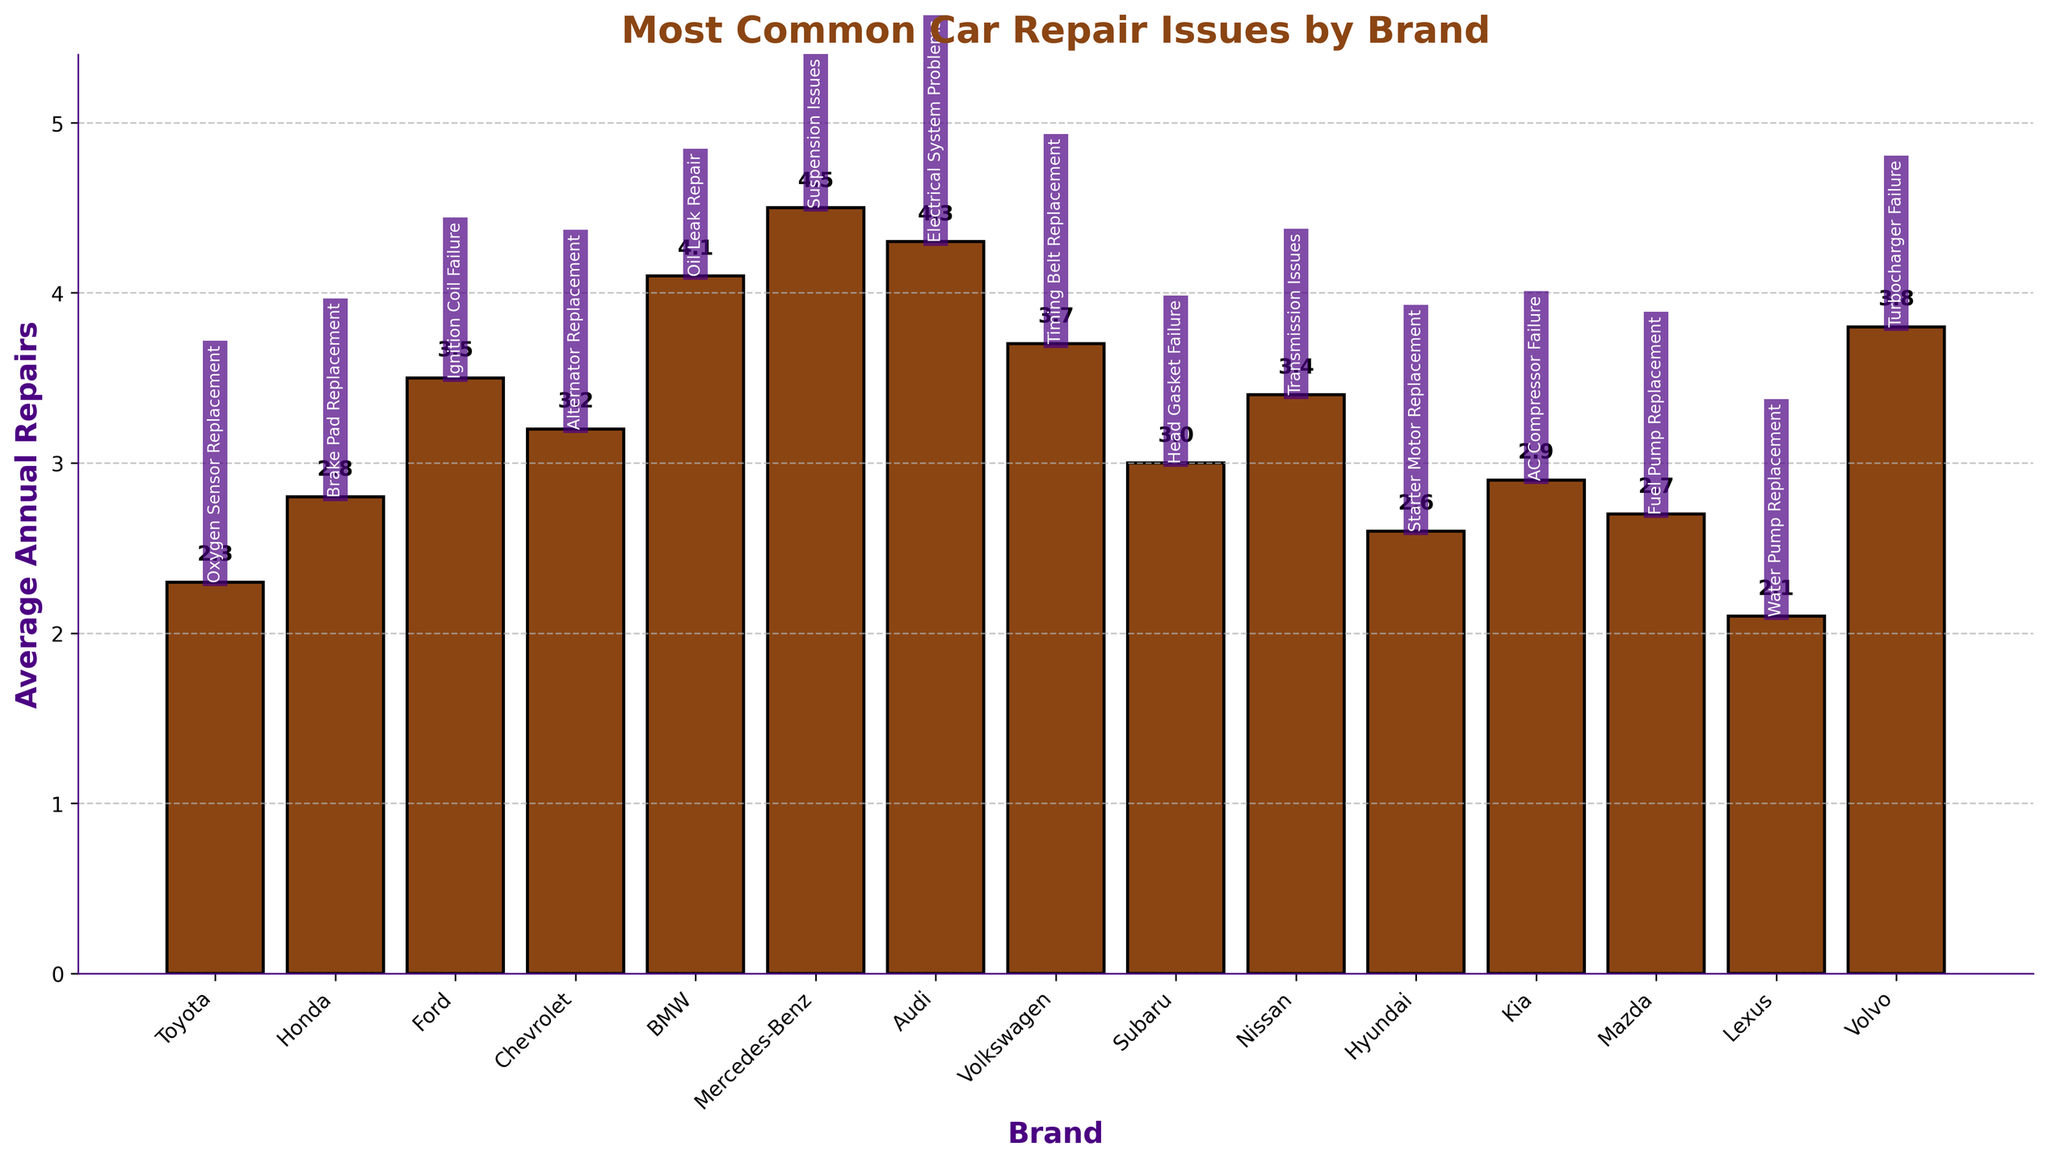Which brand has the highest average annual repairs? By inspecting the height of the bars in the chart, we can see that the bar representing Mercedes-Benz is the tallest, indicating the highest average annual repairs.
Answer: Mercedes-Benz Which brand has fewer average annual repairs, Honda or Kia? Compare the heights of the bars representing Honda and Kia. Honda has a height of 2.8 and Kia has a height of 2.9. Since 2.8 is less than 2.9, Honda has fewer average annual repairs than Kia.
Answer: Honda What is the difference in average annual repairs between BMW and Hyundai? The height of the BMW bar is 4.1 and the height of the Hyundai bar is 2.6. Subtracting these values gives 4.1 - 2.6 = 1.5.
Answer: 1.5 How many brands have an average annual repair value above 3.5? Identify and count the brands with bars exceeding the 3.5 mark. Mercedes-Benz (4.5), Audi (4.3), Volvo (3.8), and BMW (4.1) meet this criterion. There are 4 such brands.
Answer: 4 Which brands have an equal average annual repair frequency? Look for bars of equal height in the chart. Upon inspection, no two bars have exactly the same height, indicating that no brands have an equal average annual repair frequency.
Answer: None What is the most common repair issue for Toyota and how many average annual repairs does it have? Find the Toyota bar and look at the associated label above it. It shows "Oxygen Sensor Replacement" with an average of 2.3 repairs annually.
Answer: Oxygen Sensor Replacement, 2.3 Are there more brands with average annual repairs above 3 or below 3? Count the number of bars above and below the 3-mark. Above 3: Ford, Chevrolet, BMW, Mercedes-Benz, Audi, Volkswagen, Nissan, Volvo (8 brands). Below 3: Toyota, Honda, Subaru, Hyundai, Kia, Mazda, Lexus (7 brands). Since 8 is greater than 7, more brands have average annual repairs above 3.
Answer: Above 3 What is the median average annual repair value? List the average annual repairs in ascending order: 2.1, 2.3, 2.6, 2.7, 2.8, 2.9, 3.0, 3.2, 3.4, 3.5, 3.7, 3.8, 4.1, 4.3, 4.5. The median (middle) value in this 15-number list is the 8th value, which is 3.2.
Answer: 3.2 